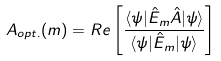Convert formula to latex. <formula><loc_0><loc_0><loc_500><loc_500>A _ { o p t . } ( m ) = R e \left [ \frac { \langle \psi | \hat { E } _ { m } \hat { A } | \psi \rangle } { \langle \psi | \hat { E } _ { m } | \psi \rangle } \right ]</formula> 